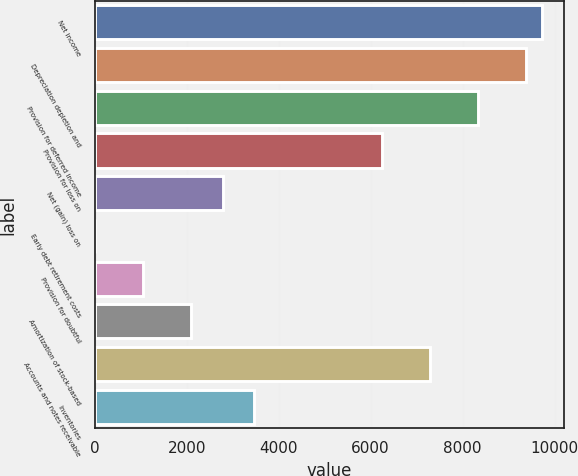<chart> <loc_0><loc_0><loc_500><loc_500><bar_chart><fcel>Net income<fcel>Depreciation depletion and<fcel>Provision for deferred income<fcel>Provision for loss on<fcel>Net (gain) loss on<fcel>Early debt retirement costs<fcel>Provision for doubtful<fcel>Amortization of stock-based<fcel>Accounts and notes receivable<fcel>Inventories<nl><fcel>9728.2<fcel>9380.8<fcel>8338.6<fcel>6254.2<fcel>2780.2<fcel>1<fcel>1043.2<fcel>2085.4<fcel>7296.4<fcel>3475<nl></chart> 